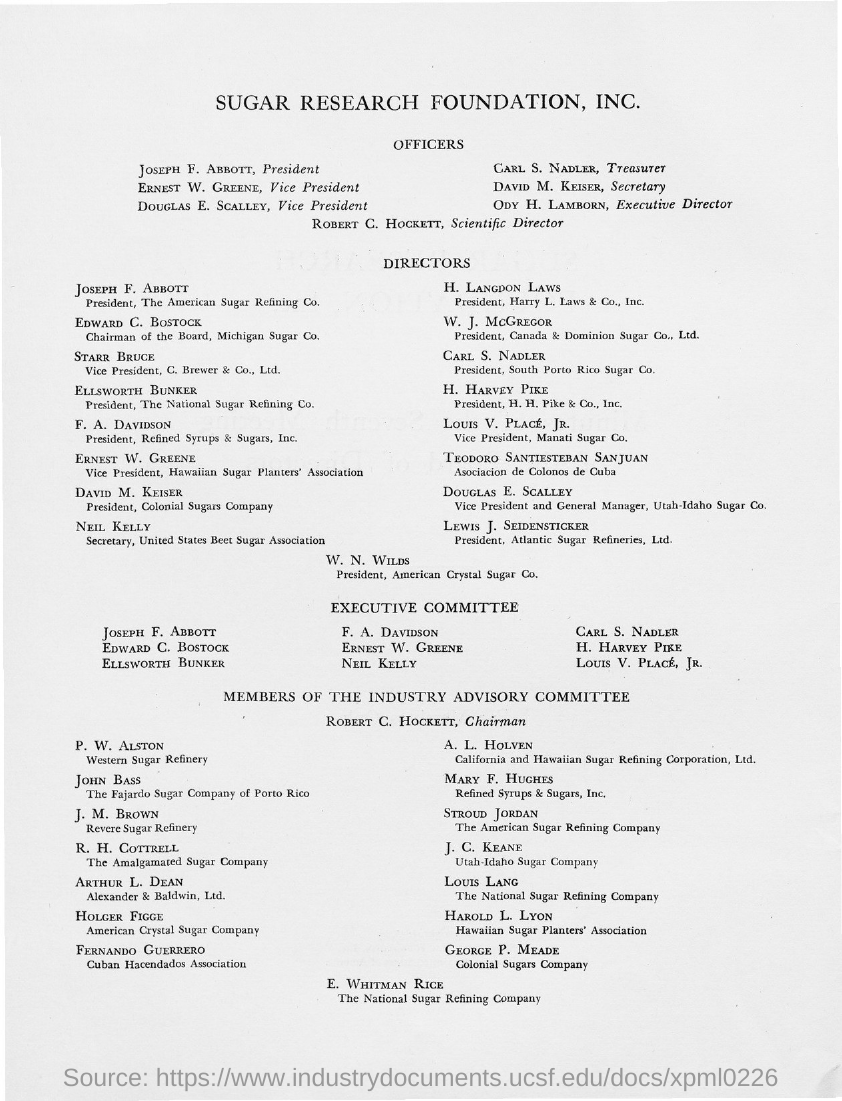List a handful of essential elements in this visual. David M. Keiser holds the position of Secretary. Ody H. Lamborn is the Executive Director. Robert C. Hockett is currently the Scientific Director at a certain organization. Carl S. Nadler holds the position of Treasurer. 